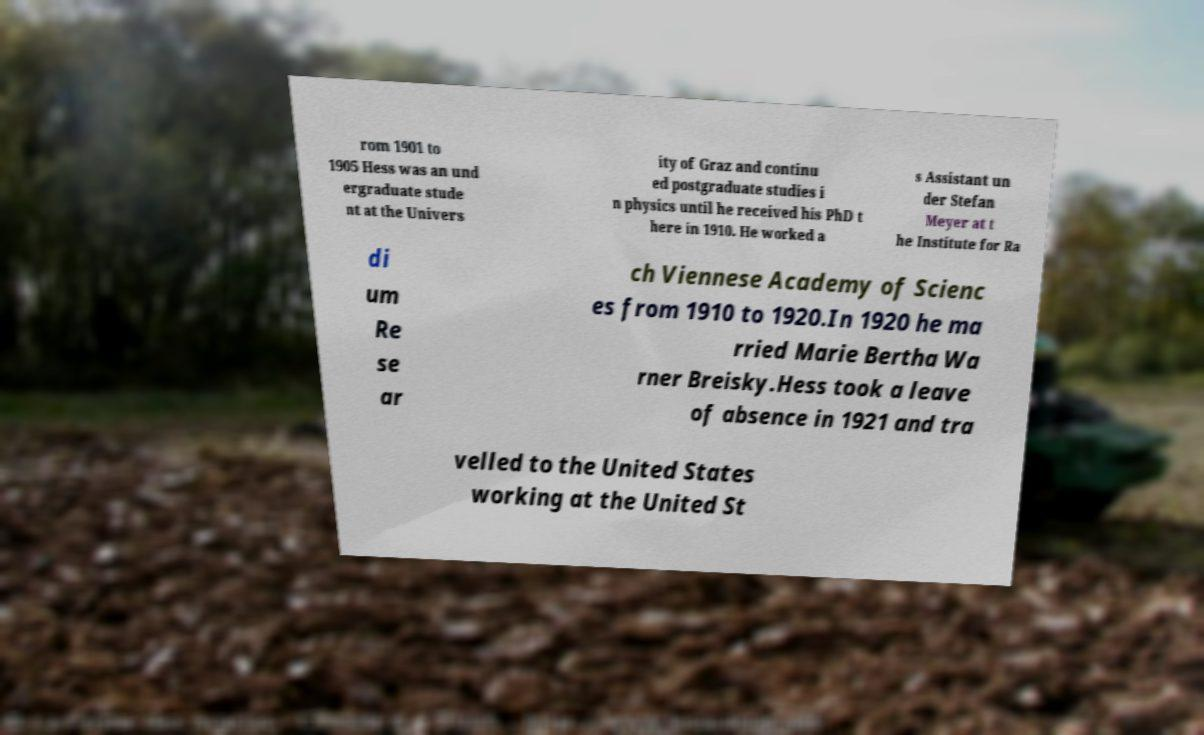Please identify and transcribe the text found in this image. rom 1901 to 1905 Hess was an und ergraduate stude nt at the Univers ity of Graz and continu ed postgraduate studies i n physics until he received his PhD t here in 1910. He worked a s Assistant un der Stefan Meyer at t he Institute for Ra di um Re se ar ch Viennese Academy of Scienc es from 1910 to 1920.In 1920 he ma rried Marie Bertha Wa rner Breisky.Hess took a leave of absence in 1921 and tra velled to the United States working at the United St 